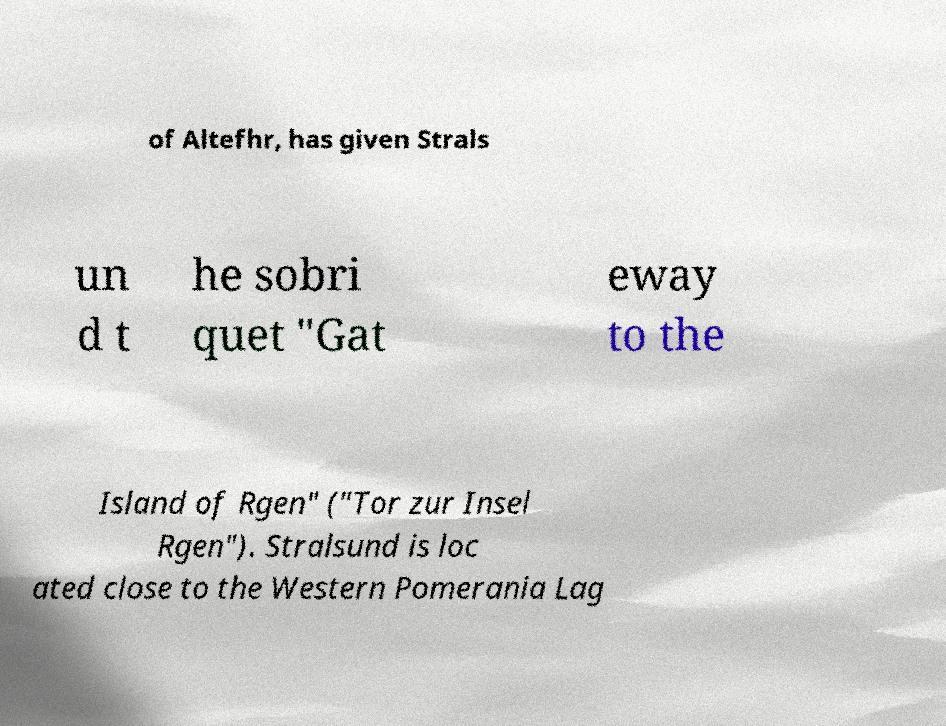Can you accurately transcribe the text from the provided image for me? of Altefhr, has given Strals un d t he sobri quet "Gat eway to the Island of Rgen" ("Tor zur Insel Rgen"). Stralsund is loc ated close to the Western Pomerania Lag 